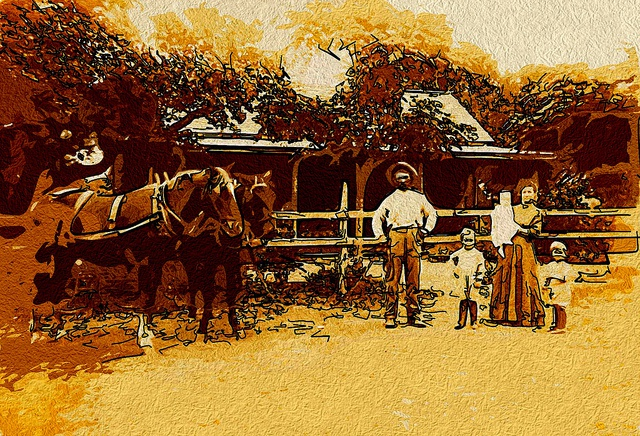Describe the objects in this image and their specific colors. I can see horse in ivory, black, maroon, and brown tones, people in ivory, black, tan, maroon, and brown tones, people in ivory, black, red, maroon, and orange tones, people in ivory, black, khaki, and tan tones, and people in ivory, tan, khaki, and black tones in this image. 